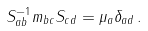<formula> <loc_0><loc_0><loc_500><loc_500>S _ { a b } ^ { - 1 } m _ { b c } S _ { c d } = \mu _ { a } \delta _ { a d } \, .</formula> 